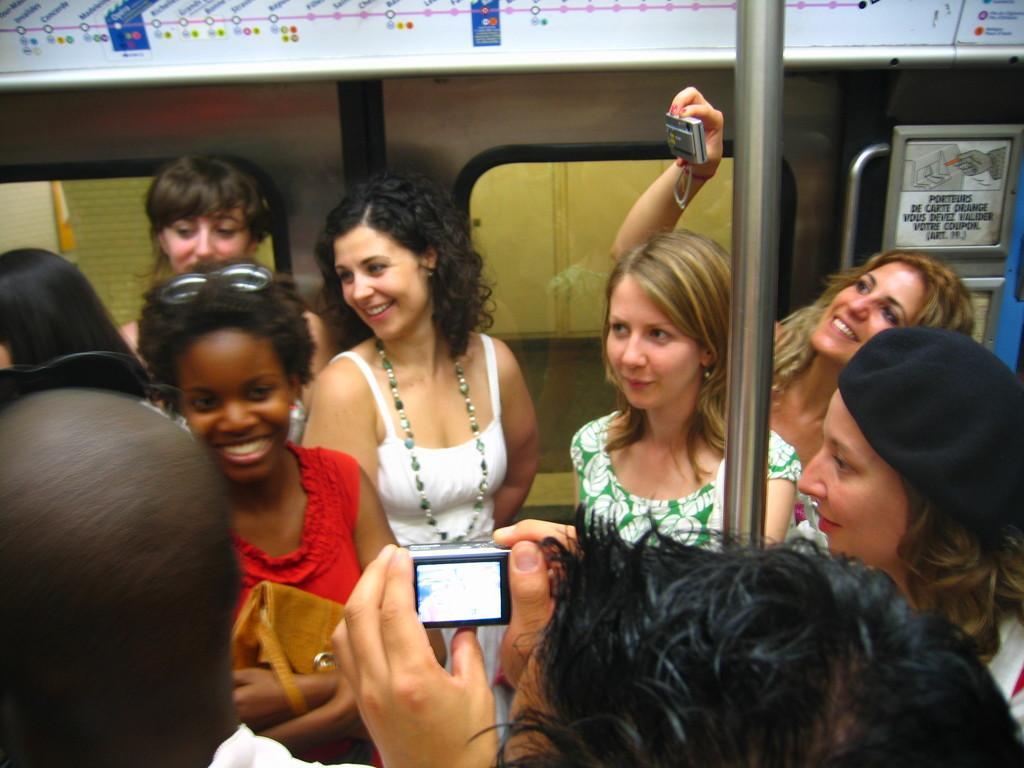In one or two sentences, can you explain what this image depicts? As we can see in the image there are group of people in the front. There is a train and these two are holding cameras. 